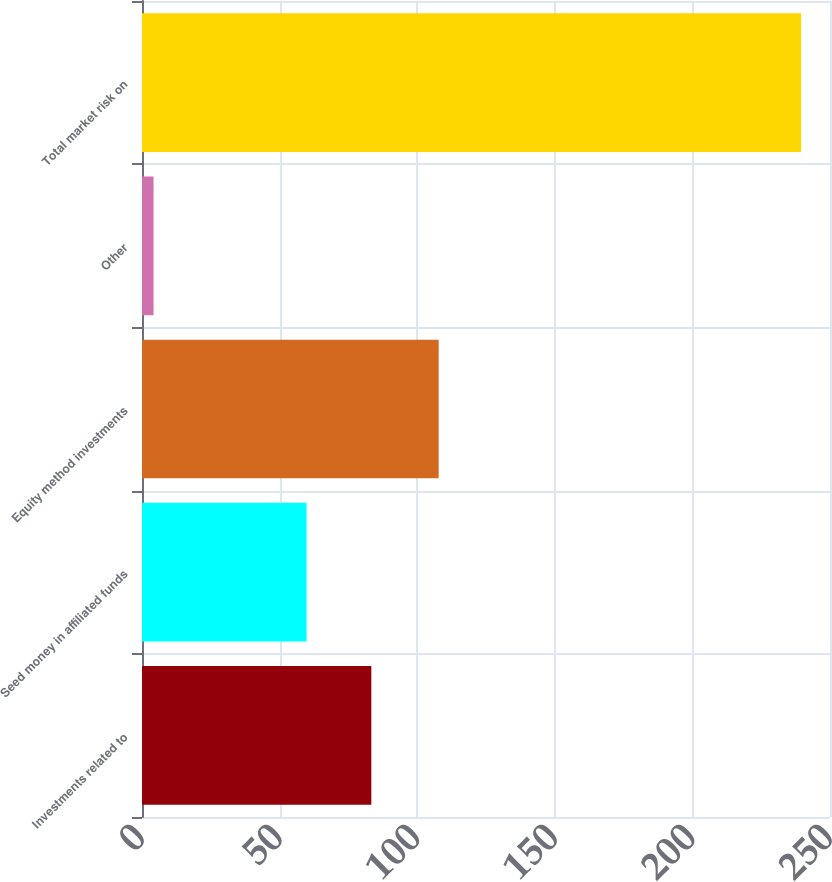Convert chart to OTSL. <chart><loc_0><loc_0><loc_500><loc_500><bar_chart><fcel>Investments related to<fcel>Seed money in affiliated funds<fcel>Equity method investments<fcel>Other<fcel>Total market risk on<nl><fcel>83.33<fcel>59.8<fcel>107.8<fcel>4.2<fcel>239.5<nl></chart> 